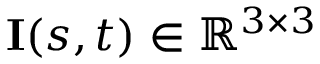Convert formula to latex. <formula><loc_0><loc_0><loc_500><loc_500>I ( s , t ) \in \mathbb { R } ^ { 3 \times 3 }</formula> 